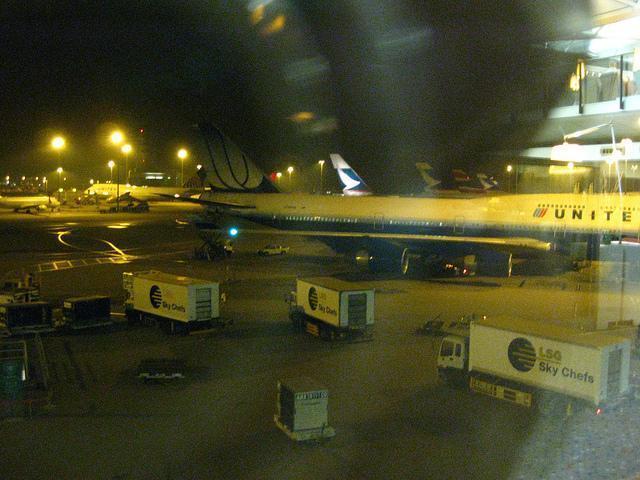How many trucks are in the picture?
Give a very brief answer. 3. How many airplanes are there?
Give a very brief answer. 2. 